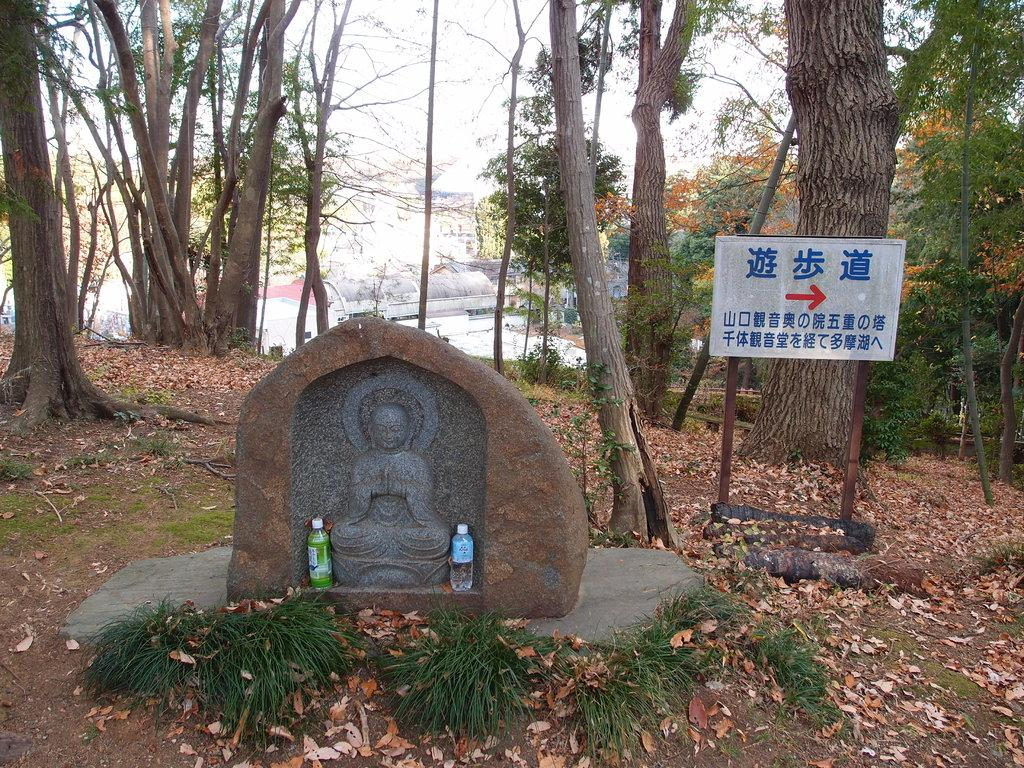How many water bottles are visible in the image? There are two water bottles in the image. What is the main subject of the image? The main subject of the image is a sculpture of a Buddha. What can be seen in the background of the image? In the background of the image, there are plants, a direction board, trees, buildings, and the sky. What type of invention is being used by the Buddha sculpture in the image? There is no invention present in the image; it features a sculpture of a Buddha and other background elements. How many eyes does the Buddha sculpture have in the image? The Buddha sculpture in the image is a statue and does not have eyes. 